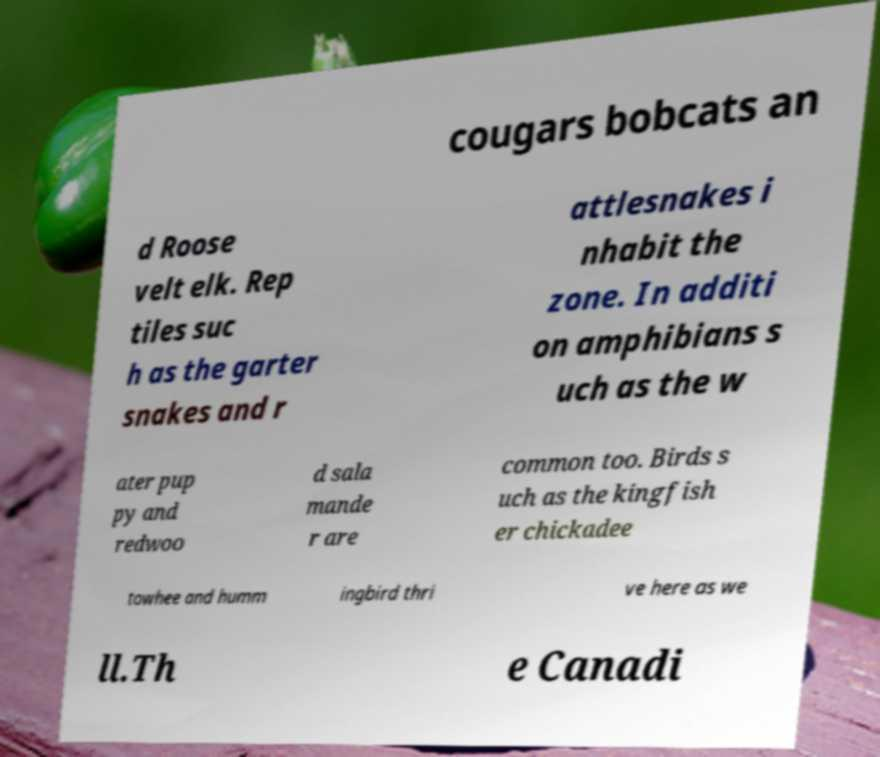For documentation purposes, I need the text within this image transcribed. Could you provide that? cougars bobcats an d Roose velt elk. Rep tiles suc h as the garter snakes and r attlesnakes i nhabit the zone. In additi on amphibians s uch as the w ater pup py and redwoo d sala mande r are common too. Birds s uch as the kingfish er chickadee towhee and humm ingbird thri ve here as we ll.Th e Canadi 